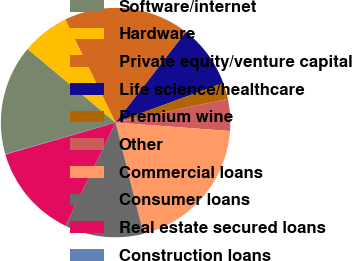Convert chart. <chart><loc_0><loc_0><loc_500><loc_500><pie_chart><fcel>Software/internet<fcel>Hardware<fcel>Private equity/venture capital<fcel>Life science/healthcare<fcel>Premium wine<fcel>Other<fcel>Commercial loans<fcel>Consumer loans<fcel>Real estate secured loans<fcel>Construction loans<nl><fcel>15.51%<fcel>6.69%<fcel>17.72%<fcel>8.9%<fcel>2.28%<fcel>4.49%<fcel>19.92%<fcel>11.1%<fcel>13.31%<fcel>0.08%<nl></chart> 